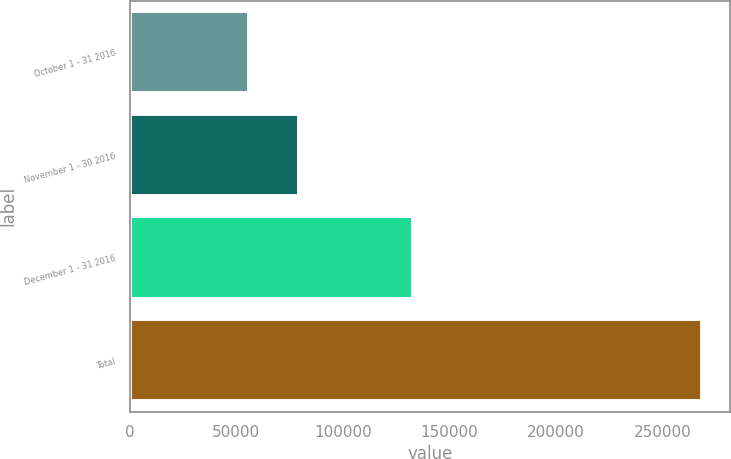Convert chart to OTSL. <chart><loc_0><loc_0><loc_500><loc_500><bar_chart><fcel>October 1 - 31 2016<fcel>November 1 - 30 2016<fcel>December 1 - 31 2016<fcel>Total<nl><fcel>56167<fcel>79335<fcel>132985<fcel>268487<nl></chart> 